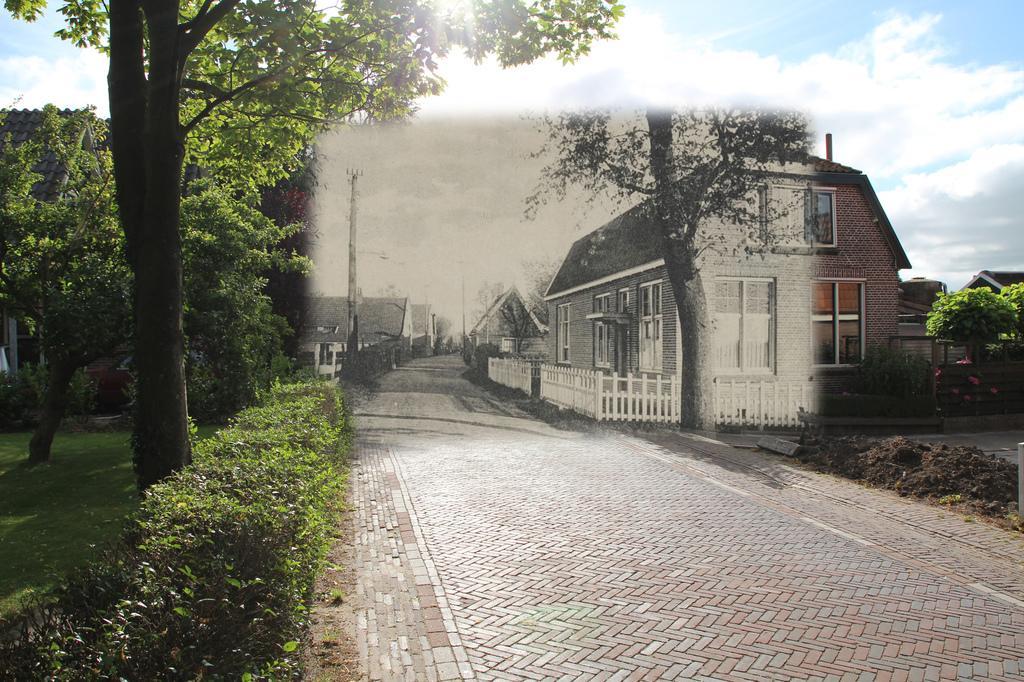How would you summarize this image in a sentence or two? In this image there is a road, on the left side there are plants and trees, in the background there are houses and the sky. 